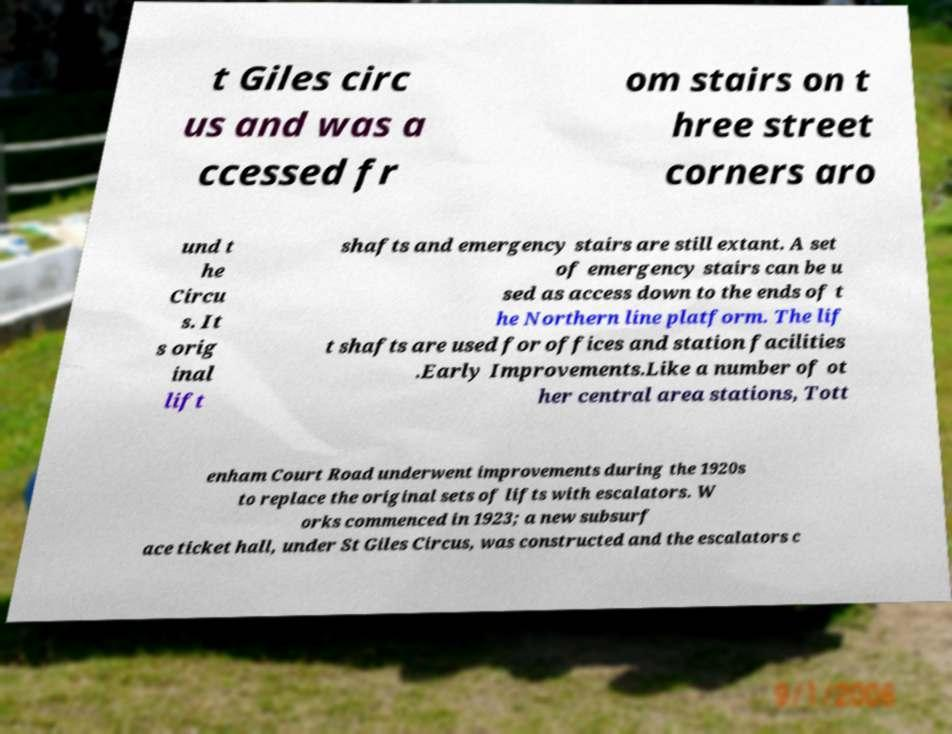Can you accurately transcribe the text from the provided image for me? t Giles circ us and was a ccessed fr om stairs on t hree street corners aro und t he Circu s. It s orig inal lift shafts and emergency stairs are still extant. A set of emergency stairs can be u sed as access down to the ends of t he Northern line platform. The lif t shafts are used for offices and station facilities .Early Improvements.Like a number of ot her central area stations, Tott enham Court Road underwent improvements during the 1920s to replace the original sets of lifts with escalators. W orks commenced in 1923; a new subsurf ace ticket hall, under St Giles Circus, was constructed and the escalators c 